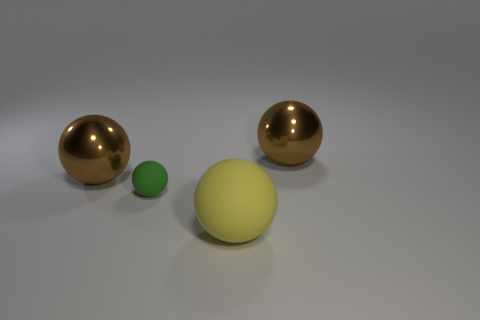Are there fewer large yellow spheres to the right of the big matte object than green balls?
Your answer should be very brief. Yes. There is a yellow object that is made of the same material as the small green sphere; what shape is it?
Give a very brief answer. Sphere. Do the small sphere and the large yellow object have the same material?
Offer a very short reply. Yes. Is the number of large yellow spheres in front of the large yellow sphere less than the number of yellow rubber things that are in front of the green matte ball?
Your answer should be compact. Yes. There is a rubber object behind the matte thing in front of the green matte thing; how many big brown metal things are left of it?
Your answer should be very brief. 1. Is there a large brown thing that has the same shape as the yellow rubber object?
Your response must be concise. Yes. Are there any brown spheres left of the brown metal sphere that is on the right side of the metal thing on the left side of the big yellow ball?
Provide a short and direct response. Yes. What color is the other matte object that is the same shape as the tiny thing?
Your answer should be very brief. Yellow. How many things are cyan objects or tiny rubber spheres?
Your answer should be very brief. 1. Does the large brown thing that is left of the small matte object have the same shape as the big object that is in front of the tiny matte thing?
Offer a terse response. Yes. 